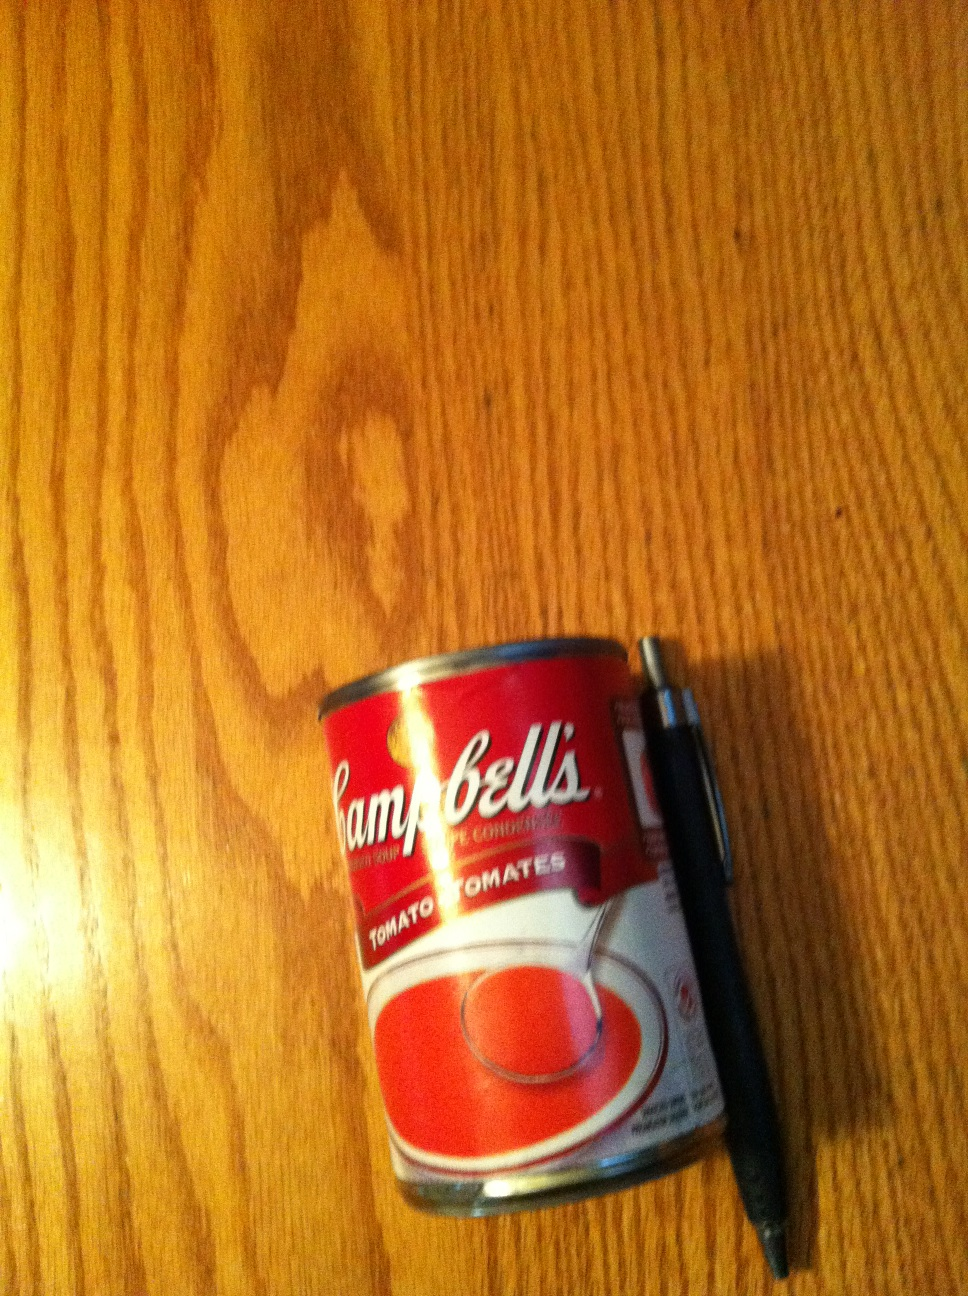What kind of recipe could you make with the content of this can? You could make a classic tomato soup by adding water or milk, heating it, and serving with a sprinkle of herbs. Alternatively, it can be used as a base for more complex dishes like tomato basil pasta, or as a sauce for a homemade pizza. Is there anything unique about this brand of tomato soup? Campbell's is known for its rich flavor and has a nostalgic value for many, often being the choice for simple comfort food. It's also versatile for cooking and can be used in various recipes that require a tomato base. 